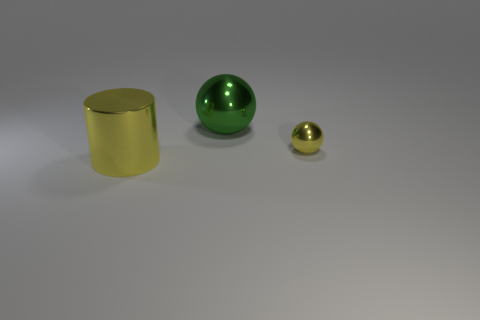How many other things are the same color as the big metal ball?
Ensure brevity in your answer.  0. How big is the yellow ball?
Your answer should be very brief. Small. Are there any rubber cylinders?
Give a very brief answer. No. Is the number of large metallic things that are to the right of the large yellow cylinder greater than the number of large green shiny spheres that are on the right side of the large green metal sphere?
Your answer should be very brief. Yes. There is a object that is both to the left of the small yellow metal thing and in front of the green shiny ball; what material is it?
Make the answer very short. Metal. Do the tiny shiny object and the large green metallic object have the same shape?
Your answer should be very brief. Yes. Is there anything else that has the same size as the yellow ball?
Make the answer very short. No. How many big metallic objects are on the right side of the cylinder?
Your answer should be very brief. 1. There is a metallic ball that is to the left of the yellow sphere; is its size the same as the metal cylinder?
Provide a succinct answer. Yes. There is a small shiny thing that is the same shape as the large green thing; what color is it?
Offer a very short reply. Yellow. 